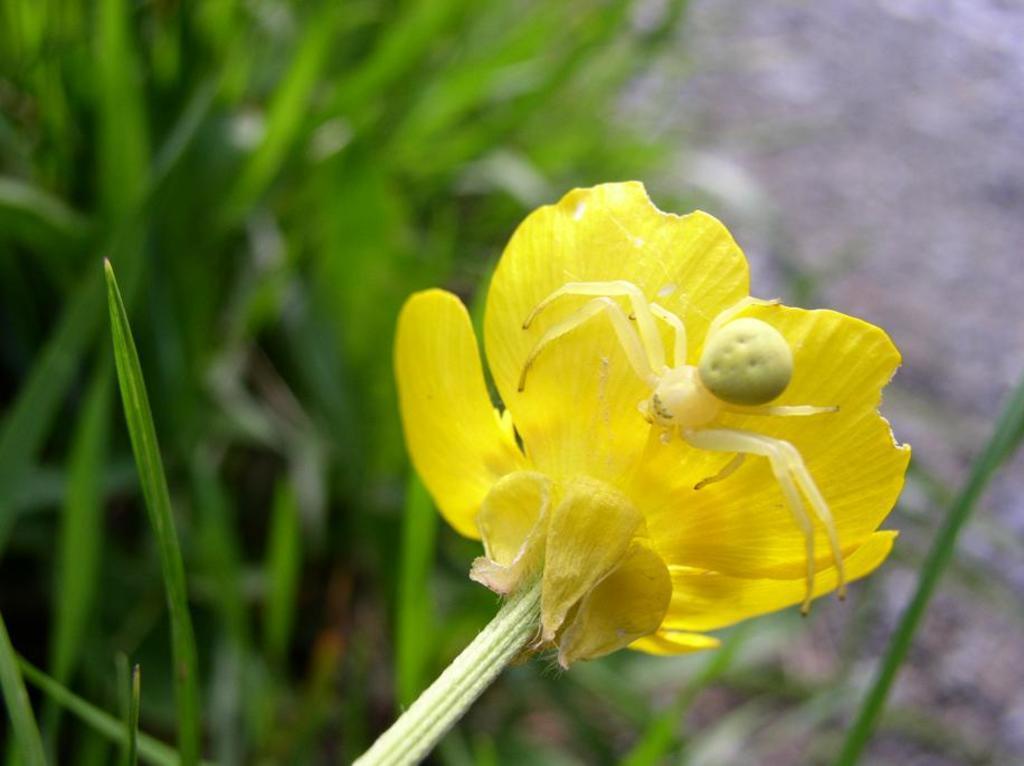Can you describe this image briefly? Here I can see an insect on a flower. The petals are in yellow color. In the background few leaves are visible. 